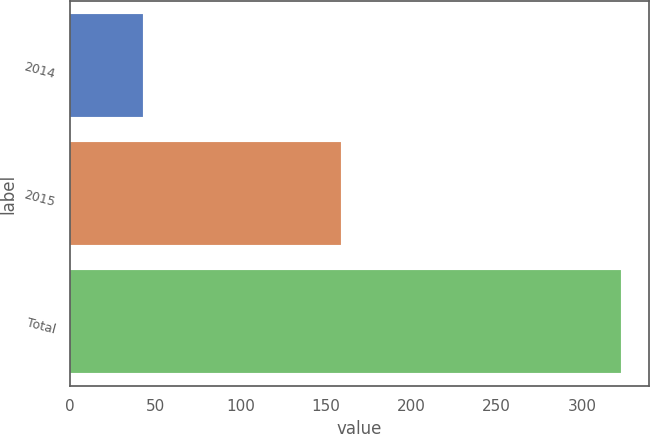Convert chart to OTSL. <chart><loc_0><loc_0><loc_500><loc_500><bar_chart><fcel>2014<fcel>2015<fcel>Total<nl><fcel>43<fcel>159<fcel>323<nl></chart> 